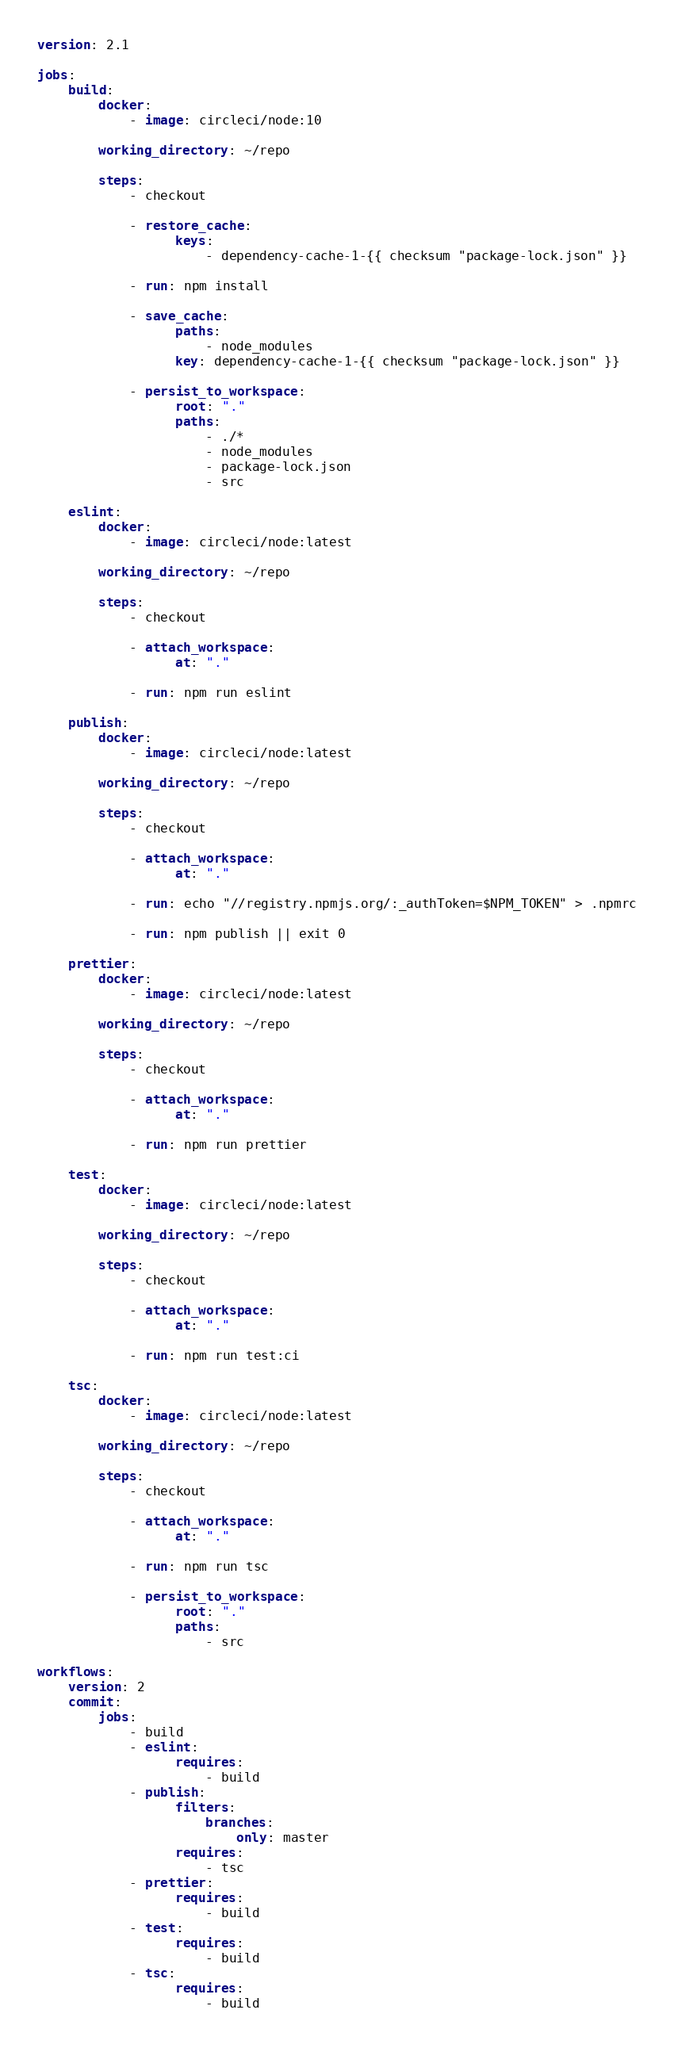Convert code to text. <code><loc_0><loc_0><loc_500><loc_500><_YAML_>version: 2.1

jobs:
    build:
        docker:
            - image: circleci/node:10

        working_directory: ~/repo

        steps:
            - checkout

            - restore_cache:
                  keys:
                      - dependency-cache-1-{{ checksum "package-lock.json" }}

            - run: npm install

            - save_cache:
                  paths:
                      - node_modules
                  key: dependency-cache-1-{{ checksum "package-lock.json" }}

            - persist_to_workspace:
                  root: "."
                  paths:
                      - ./*
                      - node_modules
                      - package-lock.json
                      - src

    eslint:
        docker:
            - image: circleci/node:latest

        working_directory: ~/repo

        steps:
            - checkout

            - attach_workspace:
                  at: "."

            - run: npm run eslint

    publish:
        docker:
            - image: circleci/node:latest

        working_directory: ~/repo

        steps:
            - checkout

            - attach_workspace:
                  at: "."

            - run: echo "//registry.npmjs.org/:_authToken=$NPM_TOKEN" > .npmrc

            - run: npm publish || exit 0

    prettier:
        docker:
            - image: circleci/node:latest

        working_directory: ~/repo

        steps:
            - checkout

            - attach_workspace:
                  at: "."

            - run: npm run prettier

    test:
        docker:
            - image: circleci/node:latest

        working_directory: ~/repo

        steps:
            - checkout

            - attach_workspace:
                  at: "."

            - run: npm run test:ci

    tsc:
        docker:
            - image: circleci/node:latest

        working_directory: ~/repo

        steps:
            - checkout

            - attach_workspace:
                  at: "."

            - run: npm run tsc

            - persist_to_workspace:
                  root: "."
                  paths:
                      - src

workflows:
    version: 2
    commit:
        jobs:
            - build
            - eslint:
                  requires:
                      - build
            - publish:
                  filters:
                      branches:
                          only: master
                  requires:
                      - tsc
            - prettier:
                  requires:
                      - build
            - test:
                  requires:
                      - build
            - tsc:
                  requires:
                      - build
</code> 